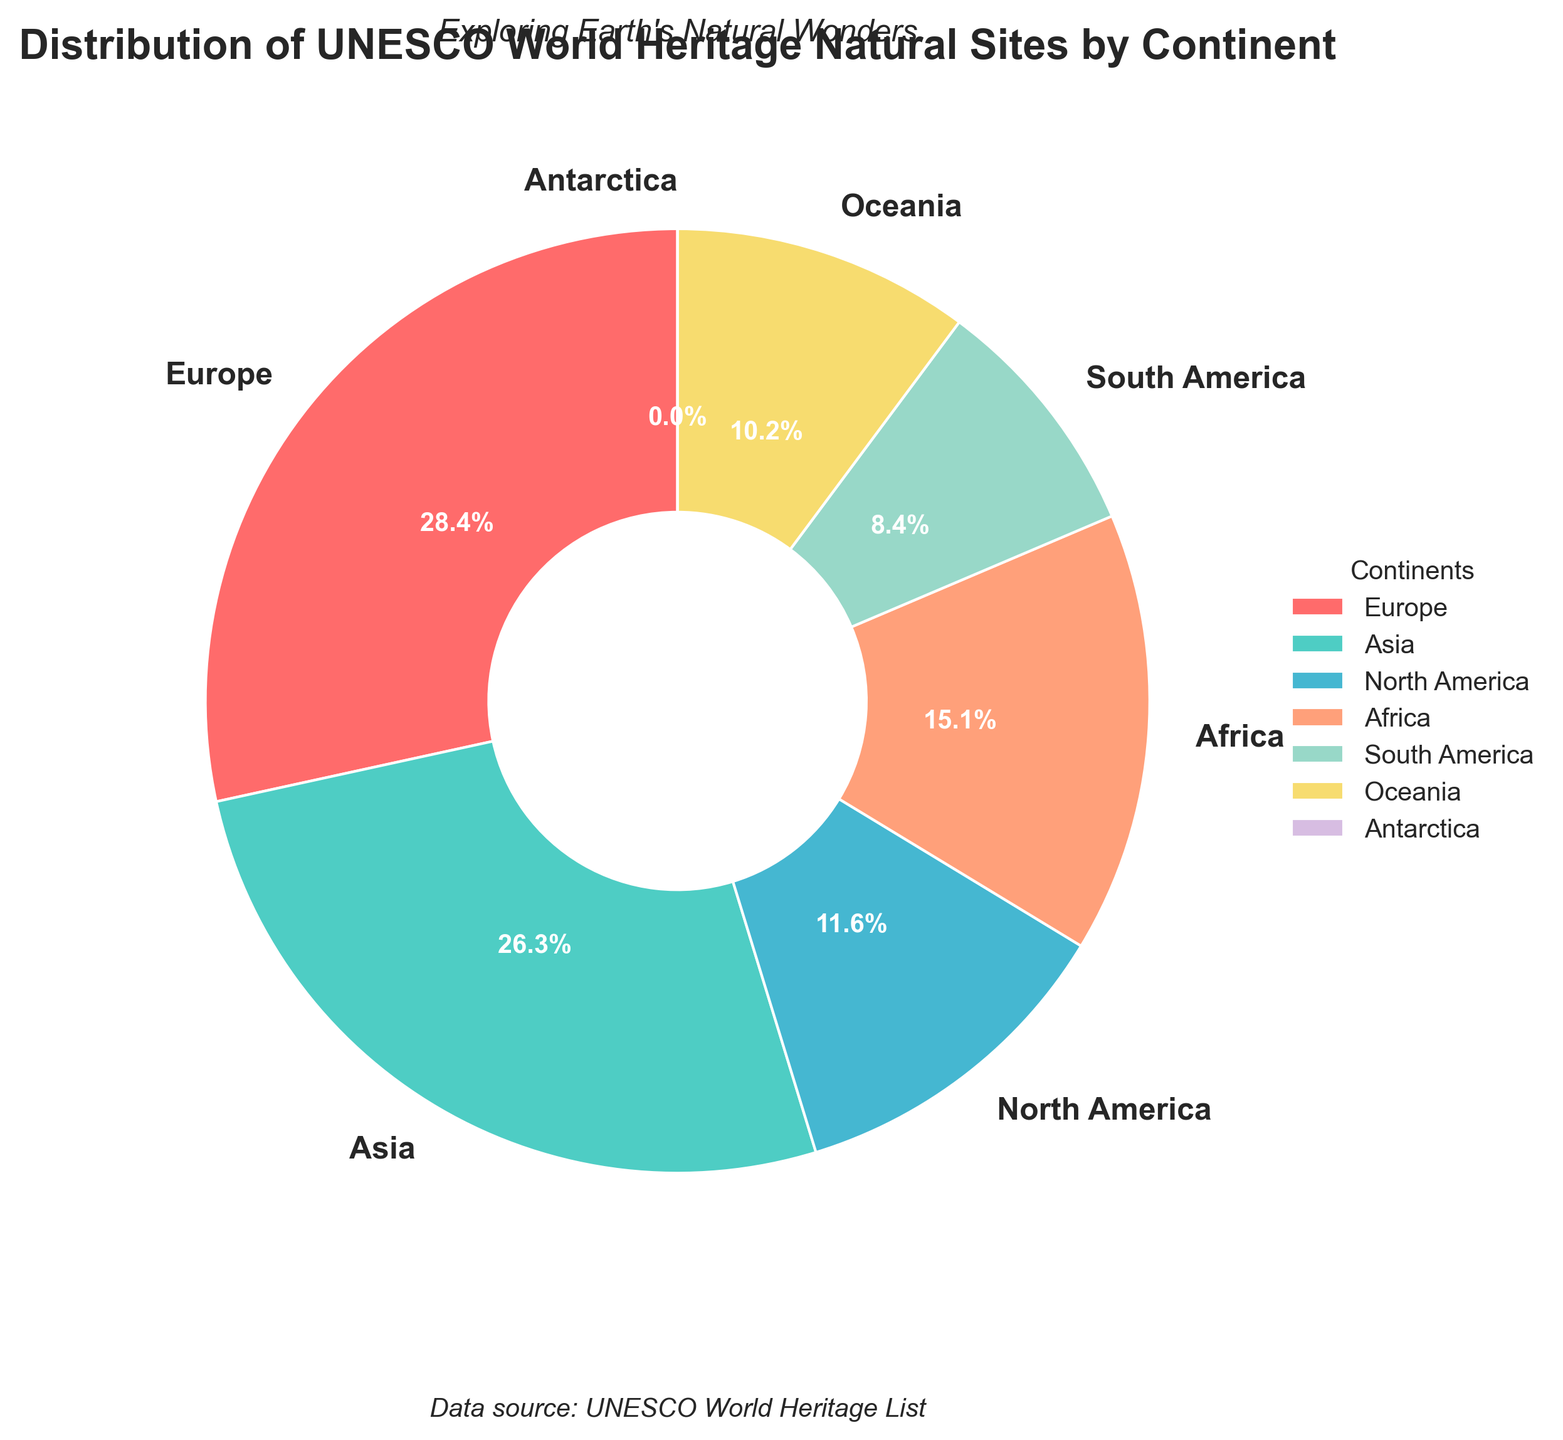What continent has the highest number of UNESCO World Heritage Natural Sites? The pie chart shows that Europe has the largest slice of the pie, which means it has the highest number of UNESCO World Heritage Natural Sites among all continents.
Answer: Europe Which continent has fewer UNESCO World Heritage Natural Sites, South America or Oceania? By visually comparing the slices representing South America and Oceania, we can see that South America's slice is smaller than Oceania's slice.
Answer: South America What percentage of UNESCO World Heritage Natural Sites are in Africa? The pie chart explicitly shows the percentage share for each continent. For Africa, the percentage is displayed on its corresponding slice.
Answer: 13.6% How many more UNESCO World Heritage Natural Sites does Europe have compared to North America? From the chart, we see Europe has 81 sites and North America has 33 sites. The difference is calculated as 81 - 33 = 48.
Answer: 48 What is the combined total of UNESCO World Heritage Natural Sites in Asia and Africa? According to the pie chart, Asia has 75 sites and Africa has 43 sites. Adding them together gives 75 + 43 = 118.
Answer: 118 Is there any continent with no UNESCO World Heritage Natural Sites? The pie chart includes all continents and shows that Antarctica has a slice labeled with 0 sites.
Answer: Yes Which two continents have a similar number of UNESCO World Heritage Natural Sites, and what are those numbers? By comparing the slice sizes visually, we can see that North America and Oceania have similar-sized slices. In the legend, they are labeled as 33 for North America and 29 for Oceania.
Answer: North America and Oceania; 33 and 29 What is the percentage difference between Europe's and South America's UNESCO World Heritage Natural Sites? Europe has 81 sites and South America has 24 sites. First, calculate the percentage for each. Europe's percentage is (81/285)*100 ≈ 28.4%, and South America's is (24/285)*100 ≈ 8.4%. The difference: 28.4% - 8.4% = 20%.
Answer: 20% How many more UNESCO World Heritage Natural Sites does Asia have compared to Oceania? According to the chart, Asia has 75 sites, and Oceania has 29 sites. The difference is calculated as 75 - 29 = 46.
Answer: 46 Which continent's slice is represented by a greenish color on the pie chart? By looking at the pie chart’s visual representation and the custom color palette, we see that the greenish color corresponds to Africa.
Answer: Africa 